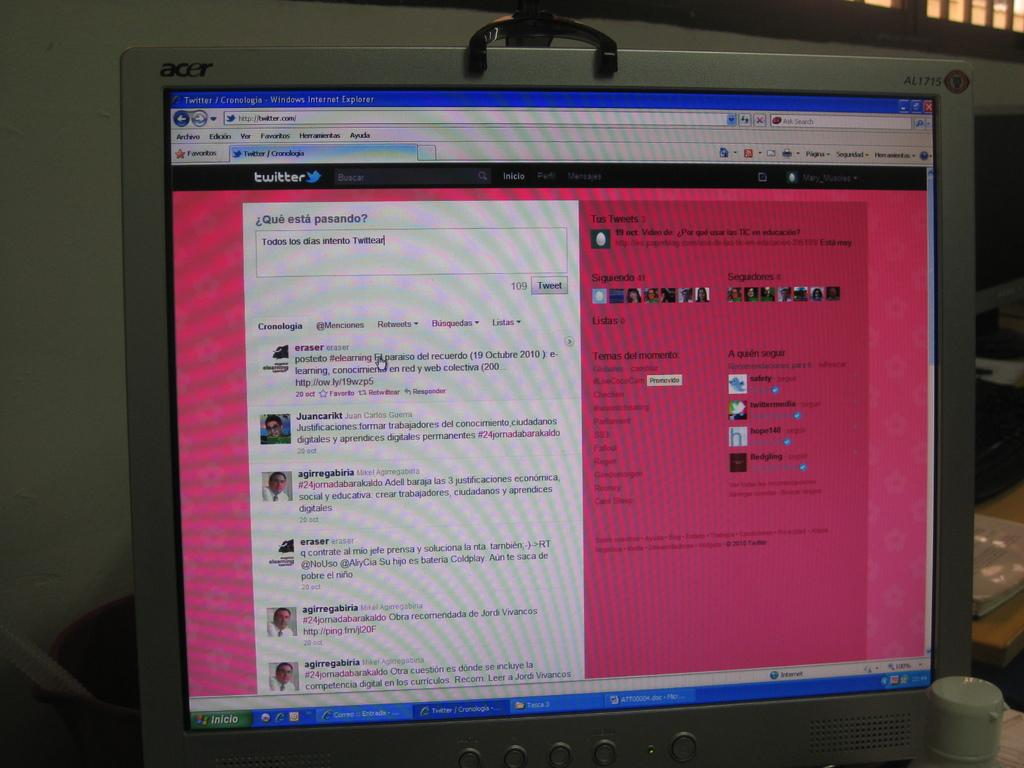<image>
Provide a brief description of the given image. a page with todos los dias written on the first page 